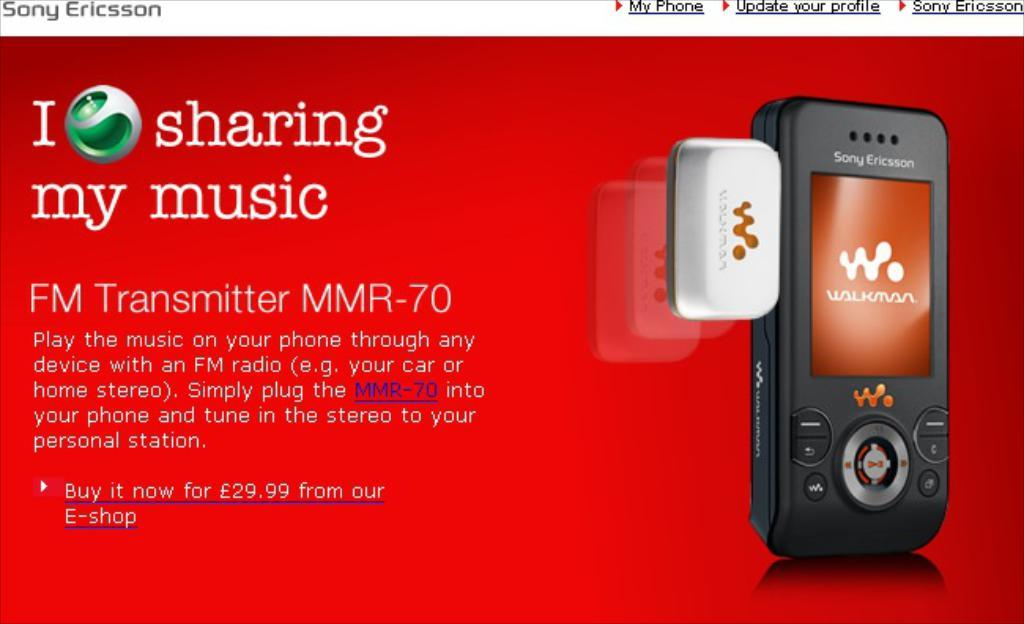Provide a one-sentence caption for the provided image. An ad by Sony Ericsson shows an FM transmitter. 